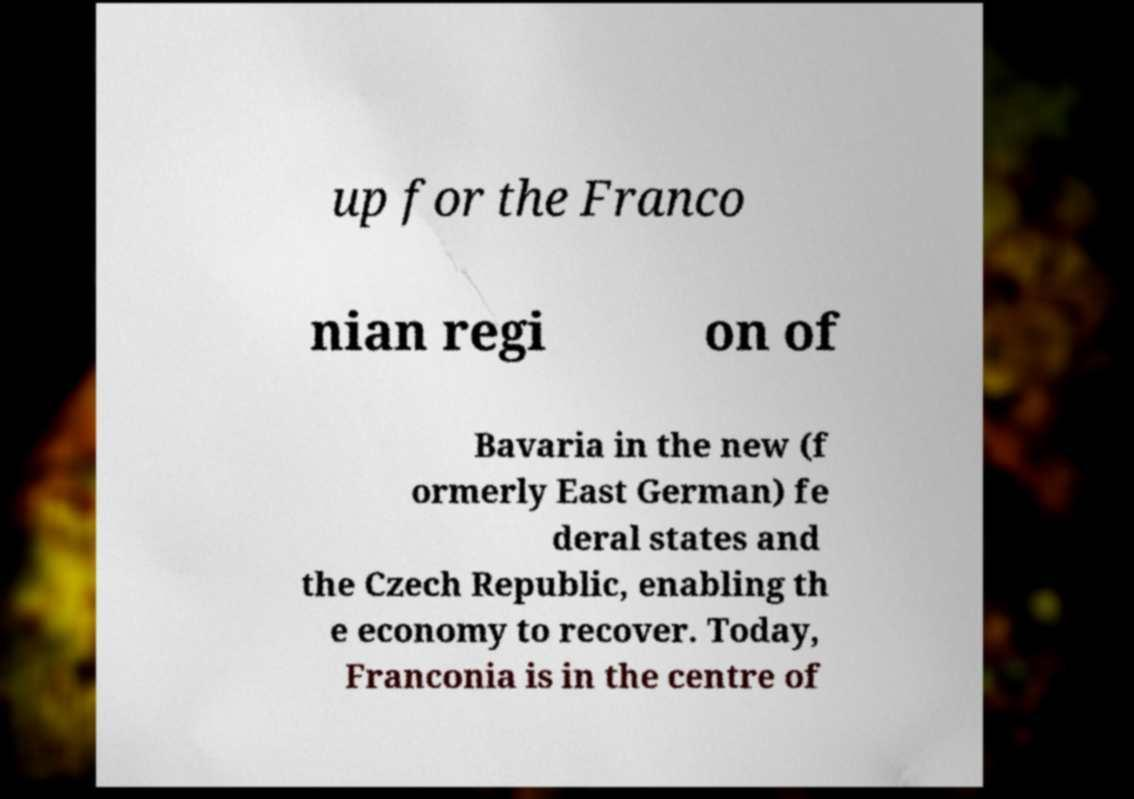Please identify and transcribe the text found in this image. up for the Franco nian regi on of Bavaria in the new (f ormerly East German) fe deral states and the Czech Republic, enabling th e economy to recover. Today, Franconia is in the centre of 